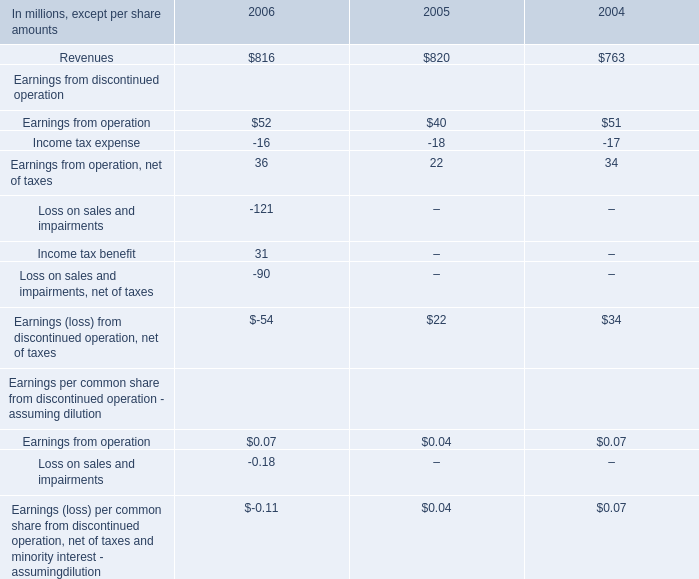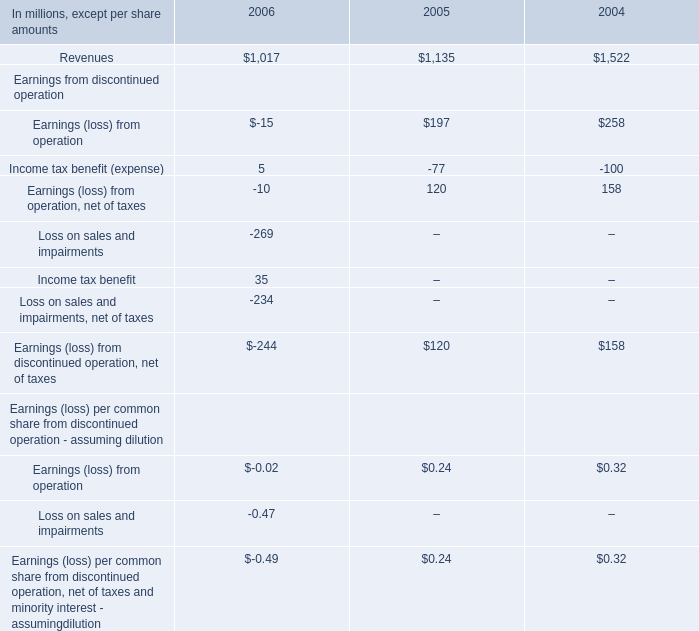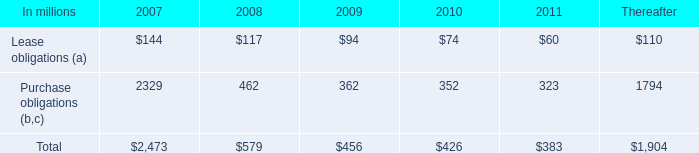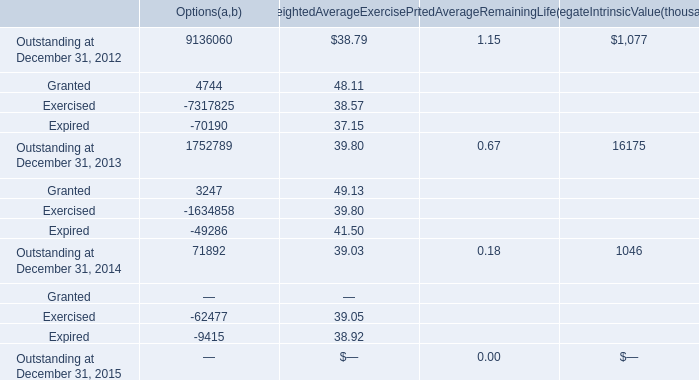What was the Weighted Average Exercise Price for Granted in the year when Weighted Average Exercise Price for Outstanding on December 31 is greater than 39.50? 
Answer: 49.13. 